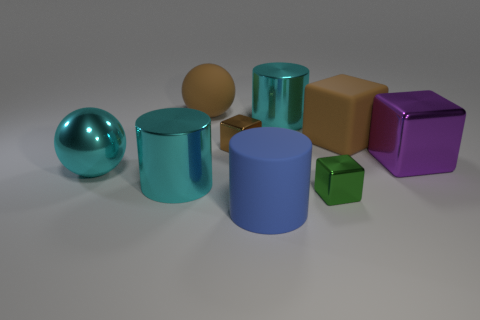Are there an equal number of purple things in front of the large rubber cylinder and big blocks?
Your answer should be very brief. No. Do the rubber cube and the blue cylinder have the same size?
Offer a very short reply. Yes. There is a large object that is to the right of the cyan ball and to the left of the large brown rubber ball; what is its material?
Offer a very short reply. Metal. What number of other big metal things are the same shape as the purple shiny thing?
Your response must be concise. 0. What material is the brown block on the right side of the blue rubber cylinder?
Your response must be concise. Rubber. Are there fewer spheres that are behind the shiny ball than yellow cylinders?
Make the answer very short. No. Does the blue rubber object have the same shape as the green object?
Your response must be concise. No. Is there any other thing that has the same shape as the blue object?
Ensure brevity in your answer.  Yes. Is there a big cyan rubber ball?
Offer a very short reply. No. Is the shape of the big purple thing the same as the brown matte thing that is right of the brown metal object?
Provide a short and direct response. Yes. 